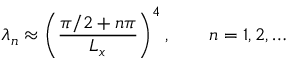<formula> <loc_0><loc_0><loc_500><loc_500>\lambda _ { n } \approx \left ( \frac { \pi / 2 + n \pi } { L _ { x } } \right ) ^ { 4 } , \quad n = 1 , 2 , \dots</formula> 